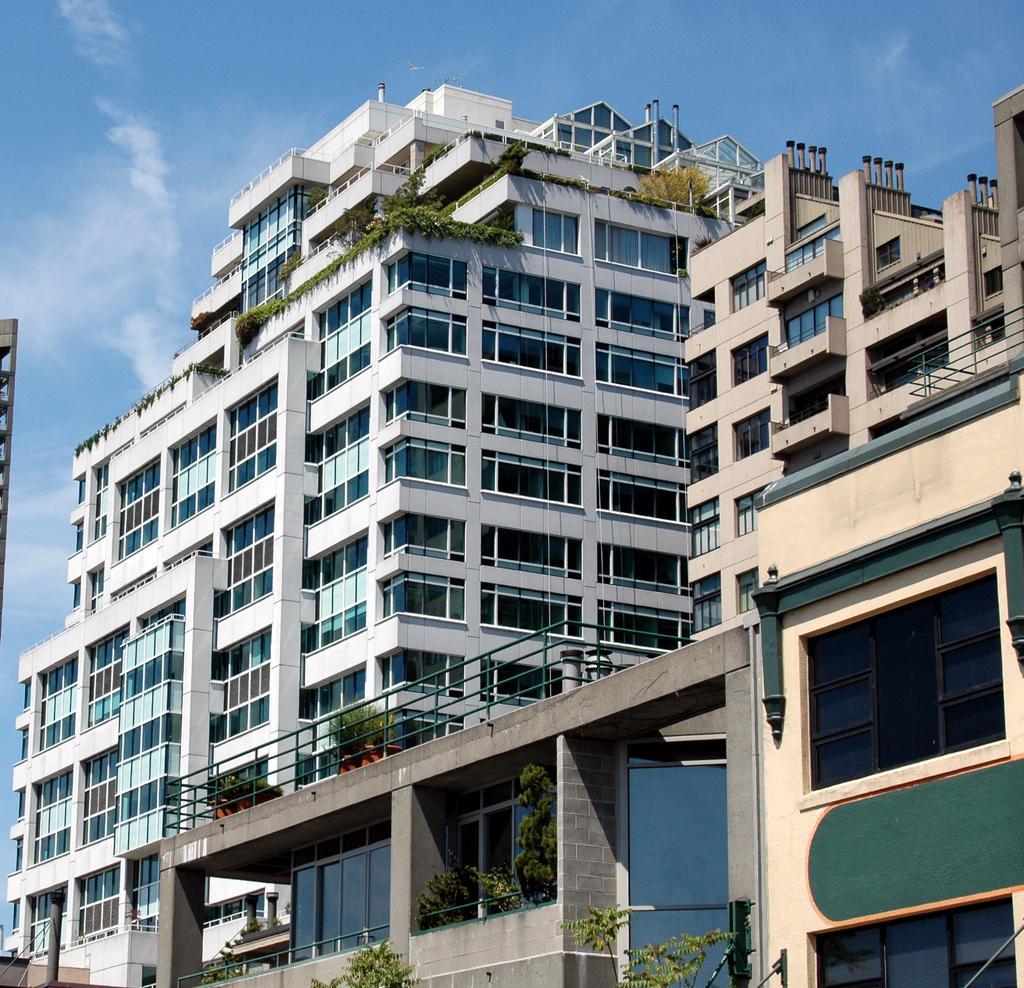How would you summarize this image in a sentence or two? In this image there are buildings. There are few plants on the buildings. The sky is cloudy. 